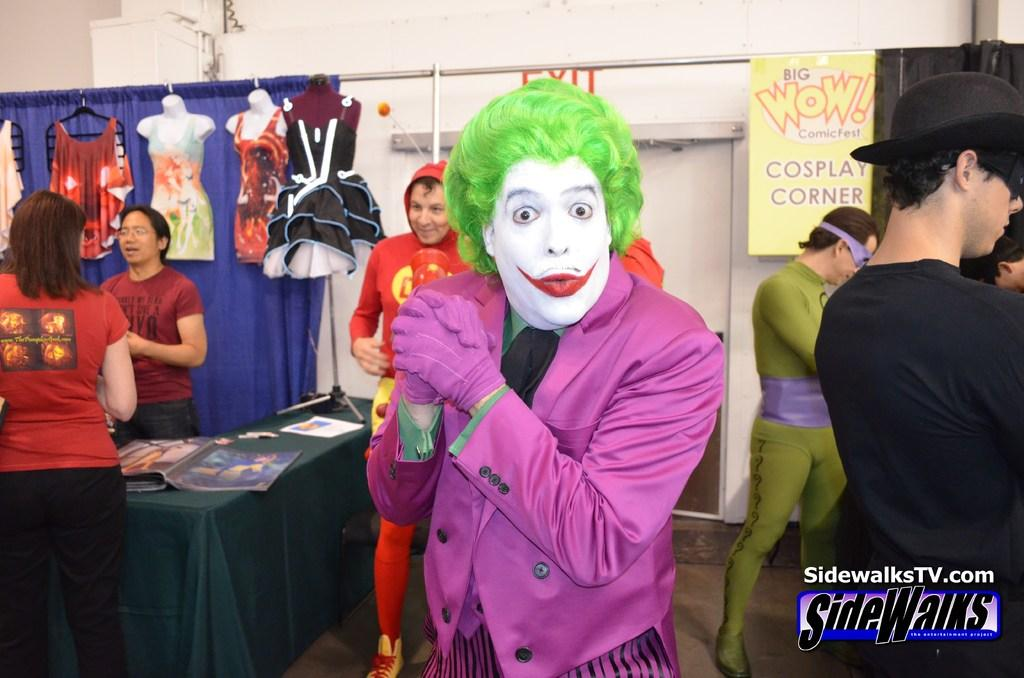<image>
Summarize the visual content of the image. a person dressed as Joker with sidewalks written next to him 